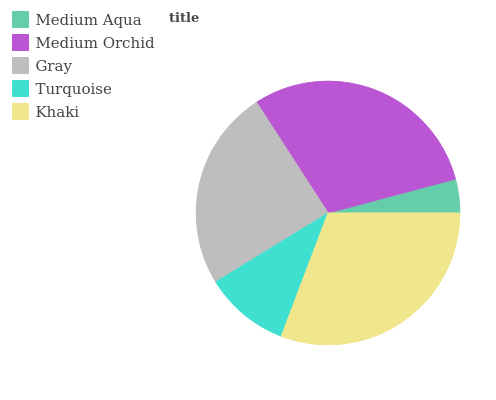Is Medium Aqua the minimum?
Answer yes or no. Yes. Is Khaki the maximum?
Answer yes or no. Yes. Is Medium Orchid the minimum?
Answer yes or no. No. Is Medium Orchid the maximum?
Answer yes or no. No. Is Medium Orchid greater than Medium Aqua?
Answer yes or no. Yes. Is Medium Aqua less than Medium Orchid?
Answer yes or no. Yes. Is Medium Aqua greater than Medium Orchid?
Answer yes or no. No. Is Medium Orchid less than Medium Aqua?
Answer yes or no. No. Is Gray the high median?
Answer yes or no. Yes. Is Gray the low median?
Answer yes or no. Yes. Is Medium Orchid the high median?
Answer yes or no. No. Is Medium Orchid the low median?
Answer yes or no. No. 